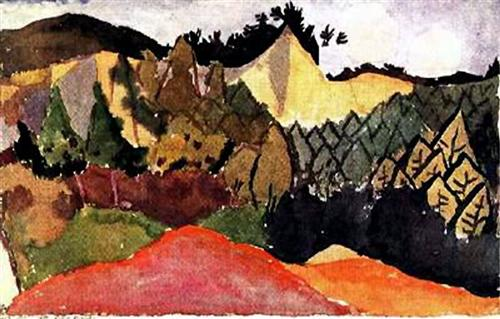Can you describe the main features of this image for me? The image is a vibrant landscape painting that captures a mountain range receding into the distance, with a valley sprawling in the foreground. The artist has employed a post-impressionist style, characterized by bold colors and loose brushstrokes, to bring this scene to life. The palette is dominated by red, yellow, and green hues, punctuated with black and white accents that add depth and contrast to the composition. The overall aesthetic and use of color suggest that this painting may be a part of the Fauvism art movement, known for its emphasis on painterly qualities and strong color over the representational or realistic values retained by Impressionism. 